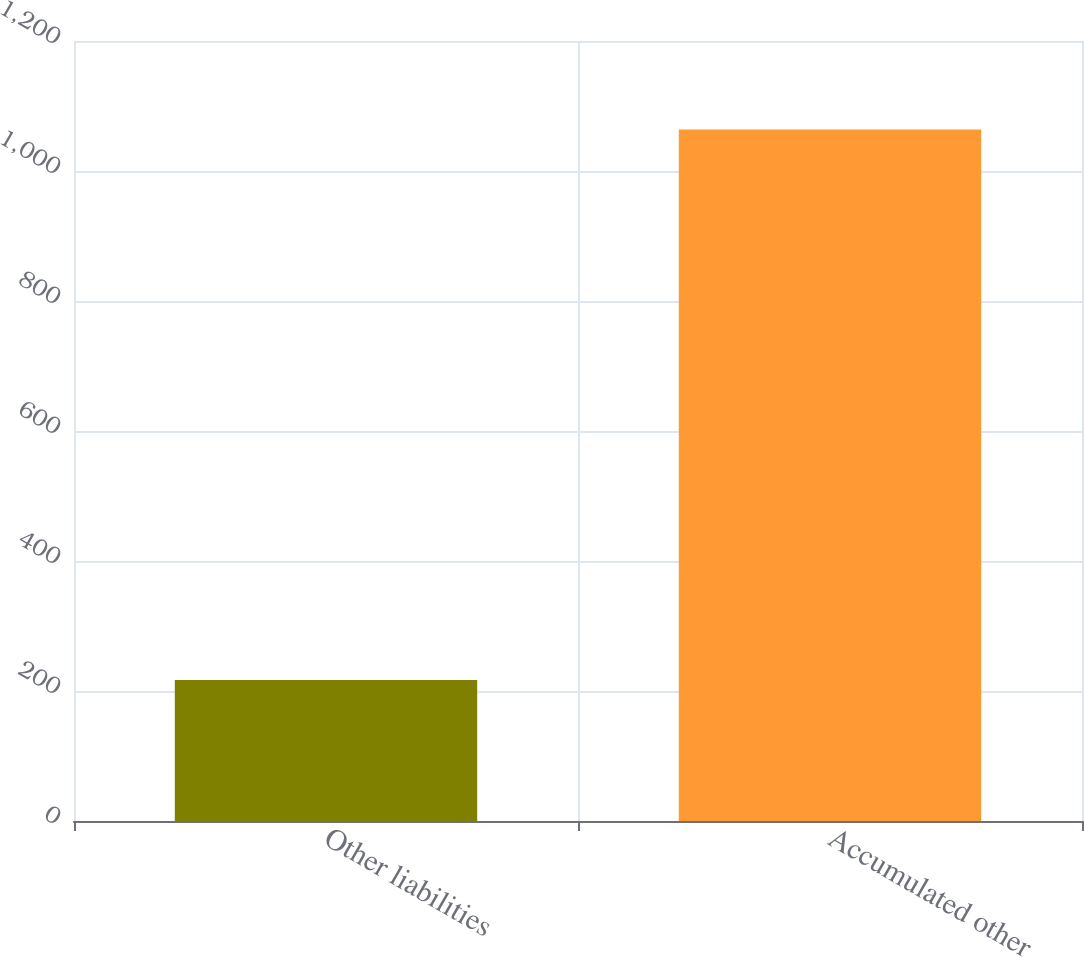Convert chart to OTSL. <chart><loc_0><loc_0><loc_500><loc_500><bar_chart><fcel>Other liabilities<fcel>Accumulated other<nl><fcel>217<fcel>1064<nl></chart> 